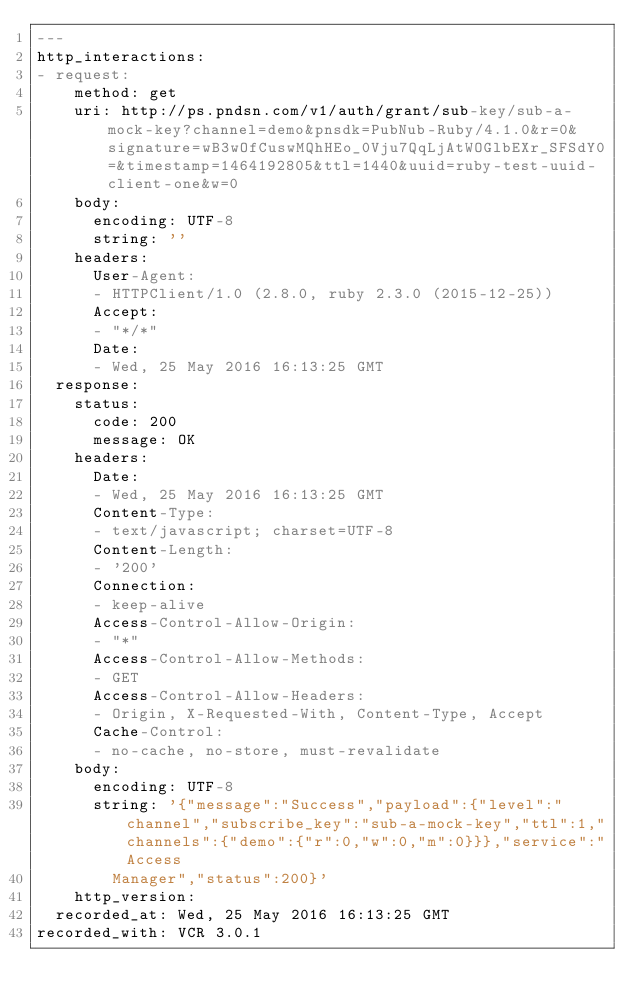<code> <loc_0><loc_0><loc_500><loc_500><_YAML_>---
http_interactions:
- request:
    method: get
    uri: http://ps.pndsn.com/v1/auth/grant/sub-key/sub-a-mock-key?channel=demo&pnsdk=PubNub-Ruby/4.1.0&r=0&signature=wB3wOfCuswMQhHEo_0Vju7QqLjAtWOGlbEXr_SFSdY0=&timestamp=1464192805&ttl=1440&uuid=ruby-test-uuid-client-one&w=0
    body:
      encoding: UTF-8
      string: ''
    headers:
      User-Agent:
      - HTTPClient/1.0 (2.8.0, ruby 2.3.0 (2015-12-25))
      Accept:
      - "*/*"
      Date:
      - Wed, 25 May 2016 16:13:25 GMT
  response:
    status:
      code: 200
      message: OK
    headers:
      Date:
      - Wed, 25 May 2016 16:13:25 GMT
      Content-Type:
      - text/javascript; charset=UTF-8
      Content-Length:
      - '200'
      Connection:
      - keep-alive
      Access-Control-Allow-Origin:
      - "*"
      Access-Control-Allow-Methods:
      - GET
      Access-Control-Allow-Headers:
      - Origin, X-Requested-With, Content-Type, Accept
      Cache-Control:
      - no-cache, no-store, must-revalidate
    body:
      encoding: UTF-8
      string: '{"message":"Success","payload":{"level":"channel","subscribe_key":"sub-a-mock-key","ttl":1,"channels":{"demo":{"r":0,"w":0,"m":0}}},"service":"Access
        Manager","status":200}'
    http_version: 
  recorded_at: Wed, 25 May 2016 16:13:25 GMT
recorded_with: VCR 3.0.1
</code> 